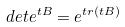<formula> <loc_0><loc_0><loc_500><loc_500>d e t e ^ { t B } = e ^ { t r ( t B ) }</formula> 